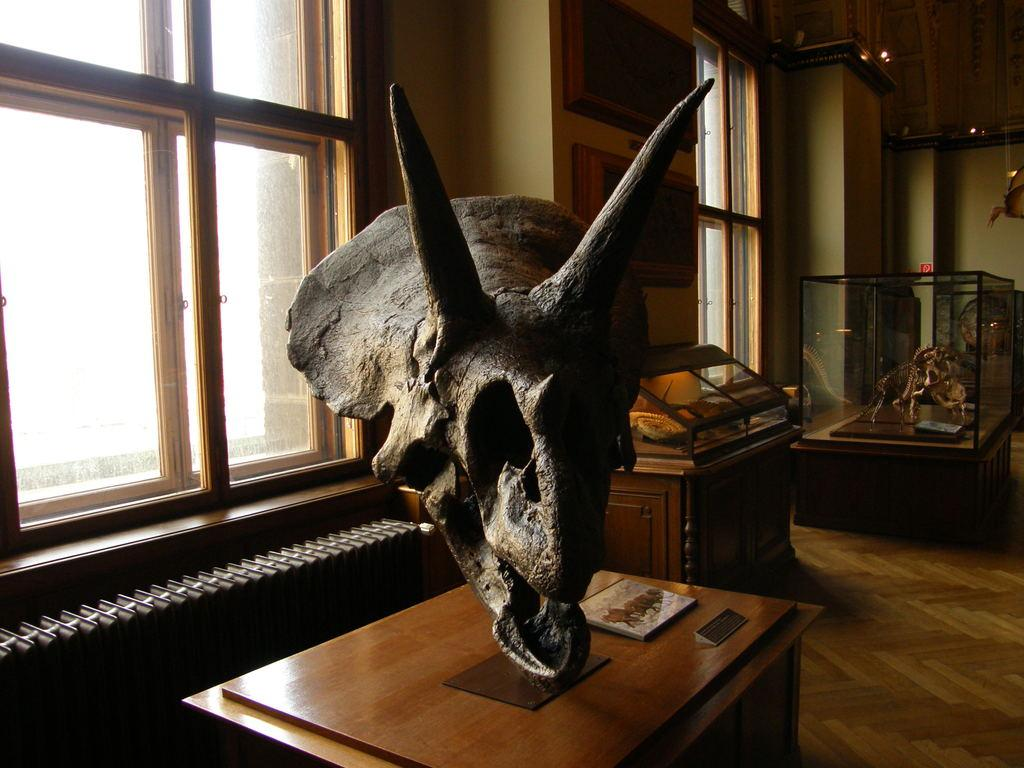What is in the background of the image? There is a wall with windows in the background. What is the wall part of? The wall is part of a floor. What is placed in a glass in the image? There are carvings placed in a glass. Where are the carvings located? The carvings are on a table. What type of bomb can be seen hidden behind the wall in the image? There is no bomb present in the image. Is there a veil covering the carvings on the table in the image? There is no veil mentioned or visible in the image; the carvings are directly on the table. 